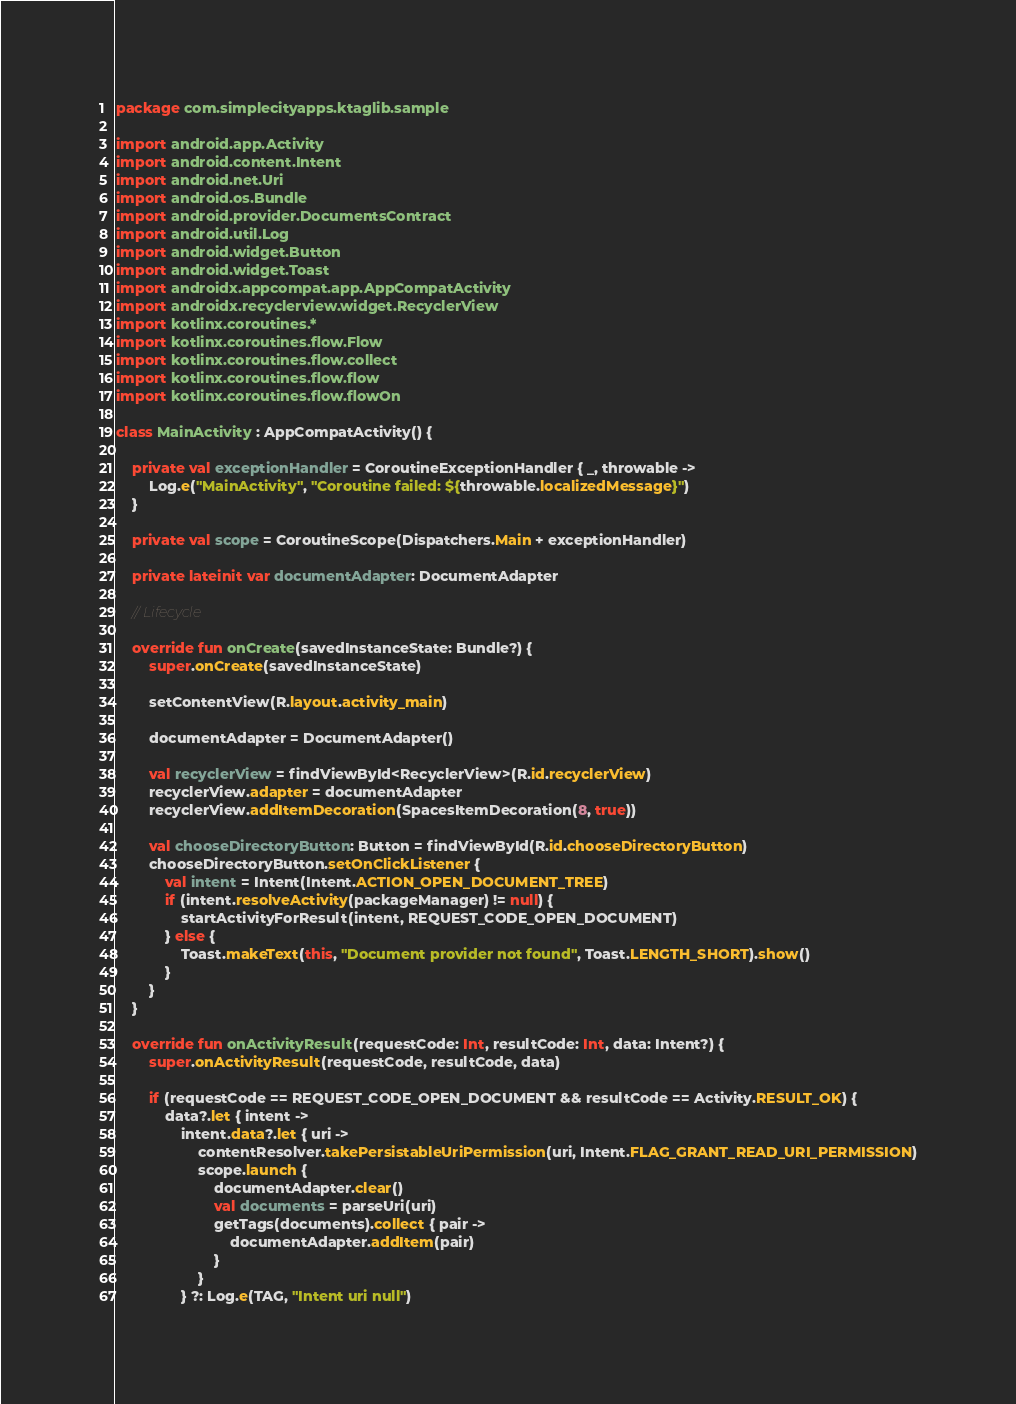<code> <loc_0><loc_0><loc_500><loc_500><_Kotlin_>package com.simplecityapps.ktaglib.sample

import android.app.Activity
import android.content.Intent
import android.net.Uri
import android.os.Bundle
import android.provider.DocumentsContract
import android.util.Log
import android.widget.Button
import android.widget.Toast
import androidx.appcompat.app.AppCompatActivity
import androidx.recyclerview.widget.RecyclerView
import kotlinx.coroutines.*
import kotlinx.coroutines.flow.Flow
import kotlinx.coroutines.flow.collect
import kotlinx.coroutines.flow.flow
import kotlinx.coroutines.flow.flowOn

class MainActivity : AppCompatActivity() {

    private val exceptionHandler = CoroutineExceptionHandler { _, throwable ->
        Log.e("MainActivity", "Coroutine failed: ${throwable.localizedMessage}")
    }

    private val scope = CoroutineScope(Dispatchers.Main + exceptionHandler)

    private lateinit var documentAdapter: DocumentAdapter

    // Lifecycle

    override fun onCreate(savedInstanceState: Bundle?) {
        super.onCreate(savedInstanceState)

        setContentView(R.layout.activity_main)

        documentAdapter = DocumentAdapter()

        val recyclerView = findViewById<RecyclerView>(R.id.recyclerView)
        recyclerView.adapter = documentAdapter
        recyclerView.addItemDecoration(SpacesItemDecoration(8, true))

        val chooseDirectoryButton: Button = findViewById(R.id.chooseDirectoryButton)
        chooseDirectoryButton.setOnClickListener {
            val intent = Intent(Intent.ACTION_OPEN_DOCUMENT_TREE)
            if (intent.resolveActivity(packageManager) != null) {
                startActivityForResult(intent, REQUEST_CODE_OPEN_DOCUMENT)
            } else {
                Toast.makeText(this, "Document provider not found", Toast.LENGTH_SHORT).show()
            }
        }
    }

    override fun onActivityResult(requestCode: Int, resultCode: Int, data: Intent?) {
        super.onActivityResult(requestCode, resultCode, data)

        if (requestCode == REQUEST_CODE_OPEN_DOCUMENT && resultCode == Activity.RESULT_OK) {
            data?.let { intent ->
                intent.data?.let { uri ->
                    contentResolver.takePersistableUriPermission(uri, Intent.FLAG_GRANT_READ_URI_PERMISSION)
                    scope.launch {
                        documentAdapter.clear()
                        val documents = parseUri(uri)
                        getTags(documents).collect { pair ->
                            documentAdapter.addItem(pair)
                        }
                    }
                } ?: Log.e(TAG, "Intent uri null")</code> 